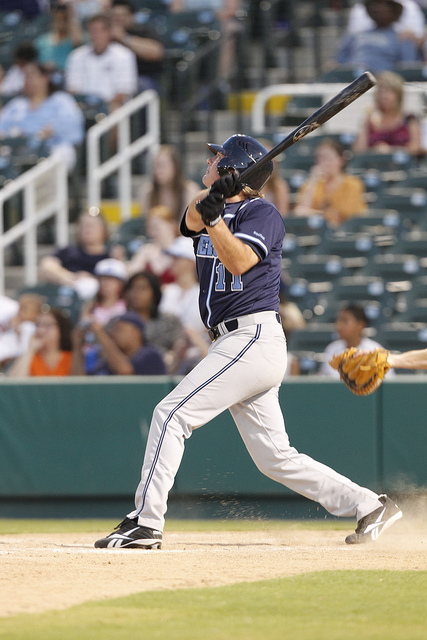Identify the text contained in this image. E 11 